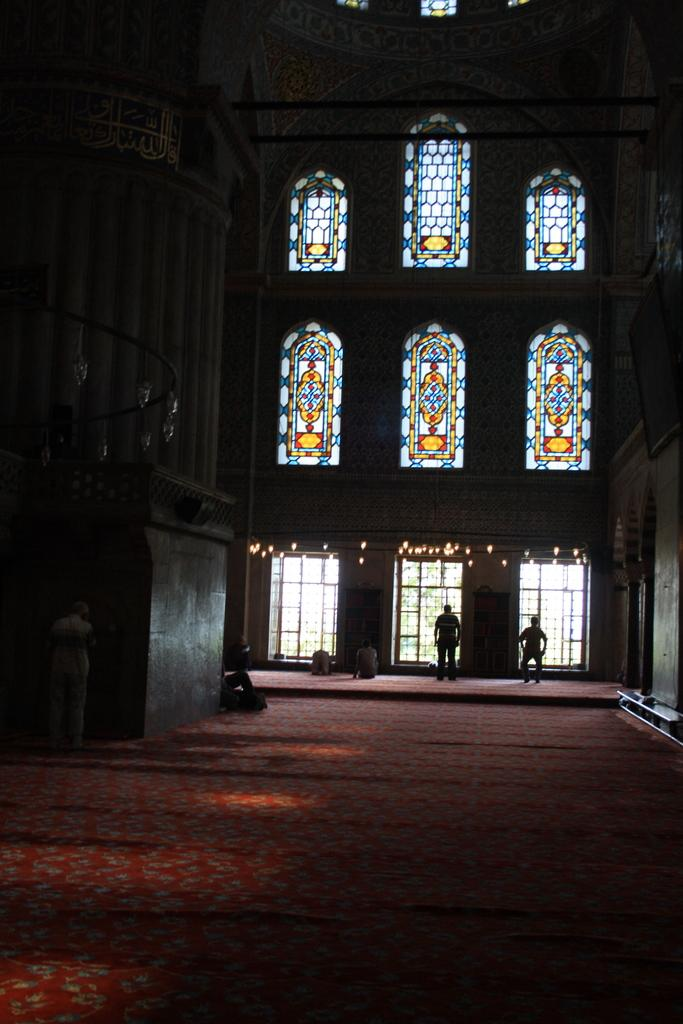What is on the floor in the image? There is a carpet on the floor in the image. What else can be seen in the image besides the carpet? There are people standing in the image. Are there any openings to the outside visible in the image? Yes, there are windows visible in the image. What type of education can be seen being provided to the deer in the image? There are no deer present in the image, and therefore no education is being provided. 